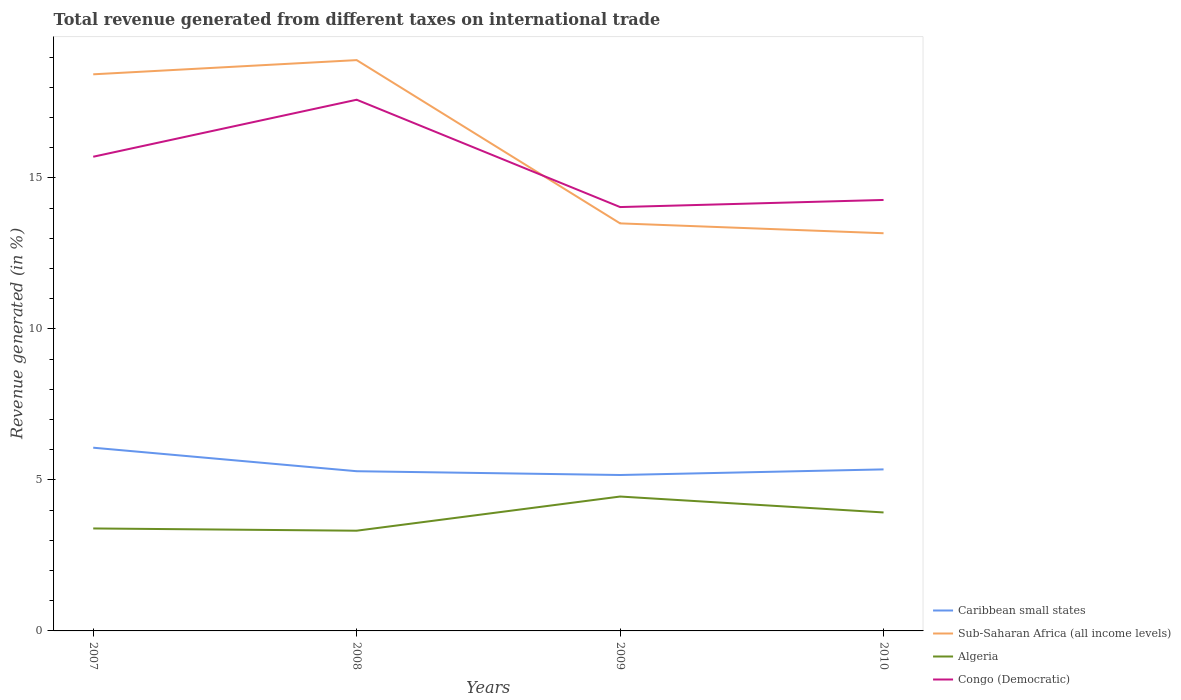How many different coloured lines are there?
Make the answer very short. 4. Is the number of lines equal to the number of legend labels?
Your answer should be very brief. Yes. Across all years, what is the maximum total revenue generated in Algeria?
Your answer should be compact. 3.32. In which year was the total revenue generated in Congo (Democratic) maximum?
Ensure brevity in your answer.  2009. What is the total total revenue generated in Sub-Saharan Africa (all income levels) in the graph?
Provide a succinct answer. 5.41. What is the difference between the highest and the second highest total revenue generated in Algeria?
Keep it short and to the point. 1.13. How many lines are there?
Ensure brevity in your answer.  4. Are the values on the major ticks of Y-axis written in scientific E-notation?
Your answer should be compact. No. Does the graph contain any zero values?
Your response must be concise. No. Does the graph contain grids?
Offer a very short reply. No. Where does the legend appear in the graph?
Your response must be concise. Bottom right. How many legend labels are there?
Offer a terse response. 4. How are the legend labels stacked?
Ensure brevity in your answer.  Vertical. What is the title of the graph?
Keep it short and to the point. Total revenue generated from different taxes on international trade. Does "San Marino" appear as one of the legend labels in the graph?
Give a very brief answer. No. What is the label or title of the X-axis?
Offer a terse response. Years. What is the label or title of the Y-axis?
Make the answer very short. Revenue generated (in %). What is the Revenue generated (in %) of Caribbean small states in 2007?
Your answer should be very brief. 6.07. What is the Revenue generated (in %) of Sub-Saharan Africa (all income levels) in 2007?
Your answer should be very brief. 18.43. What is the Revenue generated (in %) of Algeria in 2007?
Your response must be concise. 3.39. What is the Revenue generated (in %) of Congo (Democratic) in 2007?
Offer a terse response. 15.7. What is the Revenue generated (in %) in Caribbean small states in 2008?
Offer a terse response. 5.29. What is the Revenue generated (in %) in Sub-Saharan Africa (all income levels) in 2008?
Keep it short and to the point. 18.9. What is the Revenue generated (in %) of Algeria in 2008?
Offer a very short reply. 3.32. What is the Revenue generated (in %) of Congo (Democratic) in 2008?
Provide a short and direct response. 17.59. What is the Revenue generated (in %) of Caribbean small states in 2009?
Ensure brevity in your answer.  5.16. What is the Revenue generated (in %) of Sub-Saharan Africa (all income levels) in 2009?
Ensure brevity in your answer.  13.5. What is the Revenue generated (in %) of Algeria in 2009?
Your answer should be very brief. 4.45. What is the Revenue generated (in %) of Congo (Democratic) in 2009?
Your response must be concise. 14.04. What is the Revenue generated (in %) in Caribbean small states in 2010?
Offer a terse response. 5.35. What is the Revenue generated (in %) of Sub-Saharan Africa (all income levels) in 2010?
Your answer should be very brief. 13.17. What is the Revenue generated (in %) of Algeria in 2010?
Keep it short and to the point. 3.92. What is the Revenue generated (in %) of Congo (Democratic) in 2010?
Provide a short and direct response. 14.27. Across all years, what is the maximum Revenue generated (in %) in Caribbean small states?
Your answer should be very brief. 6.07. Across all years, what is the maximum Revenue generated (in %) in Sub-Saharan Africa (all income levels)?
Give a very brief answer. 18.9. Across all years, what is the maximum Revenue generated (in %) of Algeria?
Provide a short and direct response. 4.45. Across all years, what is the maximum Revenue generated (in %) in Congo (Democratic)?
Provide a succinct answer. 17.59. Across all years, what is the minimum Revenue generated (in %) of Caribbean small states?
Keep it short and to the point. 5.16. Across all years, what is the minimum Revenue generated (in %) in Sub-Saharan Africa (all income levels)?
Ensure brevity in your answer.  13.17. Across all years, what is the minimum Revenue generated (in %) in Algeria?
Make the answer very short. 3.32. Across all years, what is the minimum Revenue generated (in %) in Congo (Democratic)?
Your response must be concise. 14.04. What is the total Revenue generated (in %) of Caribbean small states in the graph?
Offer a terse response. 21.87. What is the total Revenue generated (in %) in Sub-Saharan Africa (all income levels) in the graph?
Keep it short and to the point. 64. What is the total Revenue generated (in %) of Algeria in the graph?
Ensure brevity in your answer.  15.09. What is the total Revenue generated (in %) of Congo (Democratic) in the graph?
Offer a very short reply. 61.6. What is the difference between the Revenue generated (in %) of Caribbean small states in 2007 and that in 2008?
Your response must be concise. 0.78. What is the difference between the Revenue generated (in %) of Sub-Saharan Africa (all income levels) in 2007 and that in 2008?
Offer a terse response. -0.47. What is the difference between the Revenue generated (in %) in Algeria in 2007 and that in 2008?
Your response must be concise. 0.07. What is the difference between the Revenue generated (in %) of Congo (Democratic) in 2007 and that in 2008?
Provide a short and direct response. -1.89. What is the difference between the Revenue generated (in %) of Caribbean small states in 2007 and that in 2009?
Your answer should be compact. 0.9. What is the difference between the Revenue generated (in %) of Sub-Saharan Africa (all income levels) in 2007 and that in 2009?
Keep it short and to the point. 4.94. What is the difference between the Revenue generated (in %) of Algeria in 2007 and that in 2009?
Provide a succinct answer. -1.06. What is the difference between the Revenue generated (in %) of Congo (Democratic) in 2007 and that in 2009?
Offer a terse response. 1.67. What is the difference between the Revenue generated (in %) of Caribbean small states in 2007 and that in 2010?
Your answer should be compact. 0.72. What is the difference between the Revenue generated (in %) in Sub-Saharan Africa (all income levels) in 2007 and that in 2010?
Provide a short and direct response. 5.26. What is the difference between the Revenue generated (in %) in Algeria in 2007 and that in 2010?
Keep it short and to the point. -0.53. What is the difference between the Revenue generated (in %) of Congo (Democratic) in 2007 and that in 2010?
Your answer should be very brief. 1.43. What is the difference between the Revenue generated (in %) of Caribbean small states in 2008 and that in 2009?
Provide a succinct answer. 0.13. What is the difference between the Revenue generated (in %) of Sub-Saharan Africa (all income levels) in 2008 and that in 2009?
Offer a terse response. 5.41. What is the difference between the Revenue generated (in %) of Algeria in 2008 and that in 2009?
Give a very brief answer. -1.13. What is the difference between the Revenue generated (in %) of Congo (Democratic) in 2008 and that in 2009?
Ensure brevity in your answer.  3.55. What is the difference between the Revenue generated (in %) of Caribbean small states in 2008 and that in 2010?
Offer a very short reply. -0.06. What is the difference between the Revenue generated (in %) in Sub-Saharan Africa (all income levels) in 2008 and that in 2010?
Your response must be concise. 5.73. What is the difference between the Revenue generated (in %) of Algeria in 2008 and that in 2010?
Make the answer very short. -0.6. What is the difference between the Revenue generated (in %) of Congo (Democratic) in 2008 and that in 2010?
Offer a very short reply. 3.32. What is the difference between the Revenue generated (in %) of Caribbean small states in 2009 and that in 2010?
Your response must be concise. -0.19. What is the difference between the Revenue generated (in %) of Sub-Saharan Africa (all income levels) in 2009 and that in 2010?
Make the answer very short. 0.33. What is the difference between the Revenue generated (in %) in Algeria in 2009 and that in 2010?
Make the answer very short. 0.53. What is the difference between the Revenue generated (in %) of Congo (Democratic) in 2009 and that in 2010?
Your answer should be compact. -0.24. What is the difference between the Revenue generated (in %) in Caribbean small states in 2007 and the Revenue generated (in %) in Sub-Saharan Africa (all income levels) in 2008?
Ensure brevity in your answer.  -12.84. What is the difference between the Revenue generated (in %) in Caribbean small states in 2007 and the Revenue generated (in %) in Algeria in 2008?
Provide a succinct answer. 2.75. What is the difference between the Revenue generated (in %) in Caribbean small states in 2007 and the Revenue generated (in %) in Congo (Democratic) in 2008?
Offer a terse response. -11.52. What is the difference between the Revenue generated (in %) in Sub-Saharan Africa (all income levels) in 2007 and the Revenue generated (in %) in Algeria in 2008?
Ensure brevity in your answer.  15.11. What is the difference between the Revenue generated (in %) of Sub-Saharan Africa (all income levels) in 2007 and the Revenue generated (in %) of Congo (Democratic) in 2008?
Your answer should be very brief. 0.84. What is the difference between the Revenue generated (in %) in Algeria in 2007 and the Revenue generated (in %) in Congo (Democratic) in 2008?
Your answer should be compact. -14.2. What is the difference between the Revenue generated (in %) of Caribbean small states in 2007 and the Revenue generated (in %) of Sub-Saharan Africa (all income levels) in 2009?
Your answer should be very brief. -7.43. What is the difference between the Revenue generated (in %) in Caribbean small states in 2007 and the Revenue generated (in %) in Algeria in 2009?
Your answer should be compact. 1.62. What is the difference between the Revenue generated (in %) of Caribbean small states in 2007 and the Revenue generated (in %) of Congo (Democratic) in 2009?
Ensure brevity in your answer.  -7.97. What is the difference between the Revenue generated (in %) of Sub-Saharan Africa (all income levels) in 2007 and the Revenue generated (in %) of Algeria in 2009?
Keep it short and to the point. 13.98. What is the difference between the Revenue generated (in %) of Sub-Saharan Africa (all income levels) in 2007 and the Revenue generated (in %) of Congo (Democratic) in 2009?
Your answer should be compact. 4.4. What is the difference between the Revenue generated (in %) in Algeria in 2007 and the Revenue generated (in %) in Congo (Democratic) in 2009?
Your answer should be compact. -10.64. What is the difference between the Revenue generated (in %) in Caribbean small states in 2007 and the Revenue generated (in %) in Sub-Saharan Africa (all income levels) in 2010?
Your response must be concise. -7.1. What is the difference between the Revenue generated (in %) of Caribbean small states in 2007 and the Revenue generated (in %) of Algeria in 2010?
Ensure brevity in your answer.  2.14. What is the difference between the Revenue generated (in %) in Caribbean small states in 2007 and the Revenue generated (in %) in Congo (Democratic) in 2010?
Offer a terse response. -8.2. What is the difference between the Revenue generated (in %) in Sub-Saharan Africa (all income levels) in 2007 and the Revenue generated (in %) in Algeria in 2010?
Offer a very short reply. 14.51. What is the difference between the Revenue generated (in %) in Sub-Saharan Africa (all income levels) in 2007 and the Revenue generated (in %) in Congo (Democratic) in 2010?
Give a very brief answer. 4.16. What is the difference between the Revenue generated (in %) in Algeria in 2007 and the Revenue generated (in %) in Congo (Democratic) in 2010?
Ensure brevity in your answer.  -10.88. What is the difference between the Revenue generated (in %) in Caribbean small states in 2008 and the Revenue generated (in %) in Sub-Saharan Africa (all income levels) in 2009?
Your response must be concise. -8.21. What is the difference between the Revenue generated (in %) in Caribbean small states in 2008 and the Revenue generated (in %) in Algeria in 2009?
Ensure brevity in your answer.  0.84. What is the difference between the Revenue generated (in %) in Caribbean small states in 2008 and the Revenue generated (in %) in Congo (Democratic) in 2009?
Offer a terse response. -8.75. What is the difference between the Revenue generated (in %) in Sub-Saharan Africa (all income levels) in 2008 and the Revenue generated (in %) in Algeria in 2009?
Offer a terse response. 14.45. What is the difference between the Revenue generated (in %) of Sub-Saharan Africa (all income levels) in 2008 and the Revenue generated (in %) of Congo (Democratic) in 2009?
Offer a terse response. 4.87. What is the difference between the Revenue generated (in %) in Algeria in 2008 and the Revenue generated (in %) in Congo (Democratic) in 2009?
Give a very brief answer. -10.72. What is the difference between the Revenue generated (in %) of Caribbean small states in 2008 and the Revenue generated (in %) of Sub-Saharan Africa (all income levels) in 2010?
Keep it short and to the point. -7.88. What is the difference between the Revenue generated (in %) of Caribbean small states in 2008 and the Revenue generated (in %) of Algeria in 2010?
Make the answer very short. 1.37. What is the difference between the Revenue generated (in %) in Caribbean small states in 2008 and the Revenue generated (in %) in Congo (Democratic) in 2010?
Your answer should be very brief. -8.98. What is the difference between the Revenue generated (in %) in Sub-Saharan Africa (all income levels) in 2008 and the Revenue generated (in %) in Algeria in 2010?
Offer a very short reply. 14.98. What is the difference between the Revenue generated (in %) in Sub-Saharan Africa (all income levels) in 2008 and the Revenue generated (in %) in Congo (Democratic) in 2010?
Your answer should be very brief. 4.63. What is the difference between the Revenue generated (in %) in Algeria in 2008 and the Revenue generated (in %) in Congo (Democratic) in 2010?
Your answer should be compact. -10.95. What is the difference between the Revenue generated (in %) in Caribbean small states in 2009 and the Revenue generated (in %) in Sub-Saharan Africa (all income levels) in 2010?
Your answer should be compact. -8.01. What is the difference between the Revenue generated (in %) in Caribbean small states in 2009 and the Revenue generated (in %) in Algeria in 2010?
Your response must be concise. 1.24. What is the difference between the Revenue generated (in %) in Caribbean small states in 2009 and the Revenue generated (in %) in Congo (Democratic) in 2010?
Make the answer very short. -9.11. What is the difference between the Revenue generated (in %) of Sub-Saharan Africa (all income levels) in 2009 and the Revenue generated (in %) of Algeria in 2010?
Make the answer very short. 9.57. What is the difference between the Revenue generated (in %) of Sub-Saharan Africa (all income levels) in 2009 and the Revenue generated (in %) of Congo (Democratic) in 2010?
Make the answer very short. -0.78. What is the difference between the Revenue generated (in %) in Algeria in 2009 and the Revenue generated (in %) in Congo (Democratic) in 2010?
Give a very brief answer. -9.82. What is the average Revenue generated (in %) of Caribbean small states per year?
Your response must be concise. 5.47. What is the average Revenue generated (in %) in Sub-Saharan Africa (all income levels) per year?
Offer a terse response. 16. What is the average Revenue generated (in %) of Algeria per year?
Offer a very short reply. 3.77. What is the average Revenue generated (in %) in Congo (Democratic) per year?
Provide a short and direct response. 15.4. In the year 2007, what is the difference between the Revenue generated (in %) in Caribbean small states and Revenue generated (in %) in Sub-Saharan Africa (all income levels)?
Offer a very short reply. -12.37. In the year 2007, what is the difference between the Revenue generated (in %) in Caribbean small states and Revenue generated (in %) in Algeria?
Your response must be concise. 2.67. In the year 2007, what is the difference between the Revenue generated (in %) in Caribbean small states and Revenue generated (in %) in Congo (Democratic)?
Offer a terse response. -9.64. In the year 2007, what is the difference between the Revenue generated (in %) in Sub-Saharan Africa (all income levels) and Revenue generated (in %) in Algeria?
Your answer should be compact. 15.04. In the year 2007, what is the difference between the Revenue generated (in %) of Sub-Saharan Africa (all income levels) and Revenue generated (in %) of Congo (Democratic)?
Offer a very short reply. 2.73. In the year 2007, what is the difference between the Revenue generated (in %) in Algeria and Revenue generated (in %) in Congo (Democratic)?
Provide a succinct answer. -12.31. In the year 2008, what is the difference between the Revenue generated (in %) of Caribbean small states and Revenue generated (in %) of Sub-Saharan Africa (all income levels)?
Give a very brief answer. -13.61. In the year 2008, what is the difference between the Revenue generated (in %) of Caribbean small states and Revenue generated (in %) of Algeria?
Your response must be concise. 1.97. In the year 2008, what is the difference between the Revenue generated (in %) in Caribbean small states and Revenue generated (in %) in Congo (Democratic)?
Provide a short and direct response. -12.3. In the year 2008, what is the difference between the Revenue generated (in %) in Sub-Saharan Africa (all income levels) and Revenue generated (in %) in Algeria?
Make the answer very short. 15.58. In the year 2008, what is the difference between the Revenue generated (in %) in Sub-Saharan Africa (all income levels) and Revenue generated (in %) in Congo (Democratic)?
Provide a succinct answer. 1.31. In the year 2008, what is the difference between the Revenue generated (in %) of Algeria and Revenue generated (in %) of Congo (Democratic)?
Your answer should be compact. -14.27. In the year 2009, what is the difference between the Revenue generated (in %) of Caribbean small states and Revenue generated (in %) of Sub-Saharan Africa (all income levels)?
Your answer should be compact. -8.33. In the year 2009, what is the difference between the Revenue generated (in %) of Caribbean small states and Revenue generated (in %) of Algeria?
Make the answer very short. 0.71. In the year 2009, what is the difference between the Revenue generated (in %) of Caribbean small states and Revenue generated (in %) of Congo (Democratic)?
Make the answer very short. -8.87. In the year 2009, what is the difference between the Revenue generated (in %) in Sub-Saharan Africa (all income levels) and Revenue generated (in %) in Algeria?
Offer a terse response. 9.05. In the year 2009, what is the difference between the Revenue generated (in %) of Sub-Saharan Africa (all income levels) and Revenue generated (in %) of Congo (Democratic)?
Your answer should be very brief. -0.54. In the year 2009, what is the difference between the Revenue generated (in %) in Algeria and Revenue generated (in %) in Congo (Democratic)?
Keep it short and to the point. -9.59. In the year 2010, what is the difference between the Revenue generated (in %) in Caribbean small states and Revenue generated (in %) in Sub-Saharan Africa (all income levels)?
Give a very brief answer. -7.82. In the year 2010, what is the difference between the Revenue generated (in %) in Caribbean small states and Revenue generated (in %) in Algeria?
Your answer should be very brief. 1.43. In the year 2010, what is the difference between the Revenue generated (in %) of Caribbean small states and Revenue generated (in %) of Congo (Democratic)?
Offer a very short reply. -8.92. In the year 2010, what is the difference between the Revenue generated (in %) in Sub-Saharan Africa (all income levels) and Revenue generated (in %) in Algeria?
Your answer should be very brief. 9.25. In the year 2010, what is the difference between the Revenue generated (in %) in Sub-Saharan Africa (all income levels) and Revenue generated (in %) in Congo (Democratic)?
Keep it short and to the point. -1.1. In the year 2010, what is the difference between the Revenue generated (in %) in Algeria and Revenue generated (in %) in Congo (Democratic)?
Provide a succinct answer. -10.35. What is the ratio of the Revenue generated (in %) in Caribbean small states in 2007 to that in 2008?
Make the answer very short. 1.15. What is the ratio of the Revenue generated (in %) of Sub-Saharan Africa (all income levels) in 2007 to that in 2008?
Your answer should be very brief. 0.98. What is the ratio of the Revenue generated (in %) of Algeria in 2007 to that in 2008?
Keep it short and to the point. 1.02. What is the ratio of the Revenue generated (in %) in Congo (Democratic) in 2007 to that in 2008?
Keep it short and to the point. 0.89. What is the ratio of the Revenue generated (in %) in Caribbean small states in 2007 to that in 2009?
Provide a short and direct response. 1.18. What is the ratio of the Revenue generated (in %) of Sub-Saharan Africa (all income levels) in 2007 to that in 2009?
Your answer should be very brief. 1.37. What is the ratio of the Revenue generated (in %) of Algeria in 2007 to that in 2009?
Ensure brevity in your answer.  0.76. What is the ratio of the Revenue generated (in %) of Congo (Democratic) in 2007 to that in 2009?
Keep it short and to the point. 1.12. What is the ratio of the Revenue generated (in %) in Caribbean small states in 2007 to that in 2010?
Provide a succinct answer. 1.13. What is the ratio of the Revenue generated (in %) of Sub-Saharan Africa (all income levels) in 2007 to that in 2010?
Your response must be concise. 1.4. What is the ratio of the Revenue generated (in %) of Algeria in 2007 to that in 2010?
Give a very brief answer. 0.86. What is the ratio of the Revenue generated (in %) in Congo (Democratic) in 2007 to that in 2010?
Provide a short and direct response. 1.1. What is the ratio of the Revenue generated (in %) in Caribbean small states in 2008 to that in 2009?
Keep it short and to the point. 1.02. What is the ratio of the Revenue generated (in %) in Sub-Saharan Africa (all income levels) in 2008 to that in 2009?
Your response must be concise. 1.4. What is the ratio of the Revenue generated (in %) of Algeria in 2008 to that in 2009?
Make the answer very short. 0.75. What is the ratio of the Revenue generated (in %) in Congo (Democratic) in 2008 to that in 2009?
Your response must be concise. 1.25. What is the ratio of the Revenue generated (in %) of Caribbean small states in 2008 to that in 2010?
Your response must be concise. 0.99. What is the ratio of the Revenue generated (in %) in Sub-Saharan Africa (all income levels) in 2008 to that in 2010?
Keep it short and to the point. 1.44. What is the ratio of the Revenue generated (in %) of Algeria in 2008 to that in 2010?
Make the answer very short. 0.85. What is the ratio of the Revenue generated (in %) in Congo (Democratic) in 2008 to that in 2010?
Offer a terse response. 1.23. What is the ratio of the Revenue generated (in %) in Caribbean small states in 2009 to that in 2010?
Make the answer very short. 0.97. What is the ratio of the Revenue generated (in %) in Sub-Saharan Africa (all income levels) in 2009 to that in 2010?
Offer a terse response. 1.02. What is the ratio of the Revenue generated (in %) of Algeria in 2009 to that in 2010?
Give a very brief answer. 1.13. What is the ratio of the Revenue generated (in %) of Congo (Democratic) in 2009 to that in 2010?
Give a very brief answer. 0.98. What is the difference between the highest and the second highest Revenue generated (in %) of Caribbean small states?
Your response must be concise. 0.72. What is the difference between the highest and the second highest Revenue generated (in %) in Sub-Saharan Africa (all income levels)?
Your answer should be very brief. 0.47. What is the difference between the highest and the second highest Revenue generated (in %) in Algeria?
Offer a terse response. 0.53. What is the difference between the highest and the second highest Revenue generated (in %) in Congo (Democratic)?
Provide a succinct answer. 1.89. What is the difference between the highest and the lowest Revenue generated (in %) of Caribbean small states?
Keep it short and to the point. 0.9. What is the difference between the highest and the lowest Revenue generated (in %) in Sub-Saharan Africa (all income levels)?
Your response must be concise. 5.73. What is the difference between the highest and the lowest Revenue generated (in %) of Algeria?
Your answer should be compact. 1.13. What is the difference between the highest and the lowest Revenue generated (in %) of Congo (Democratic)?
Provide a short and direct response. 3.55. 